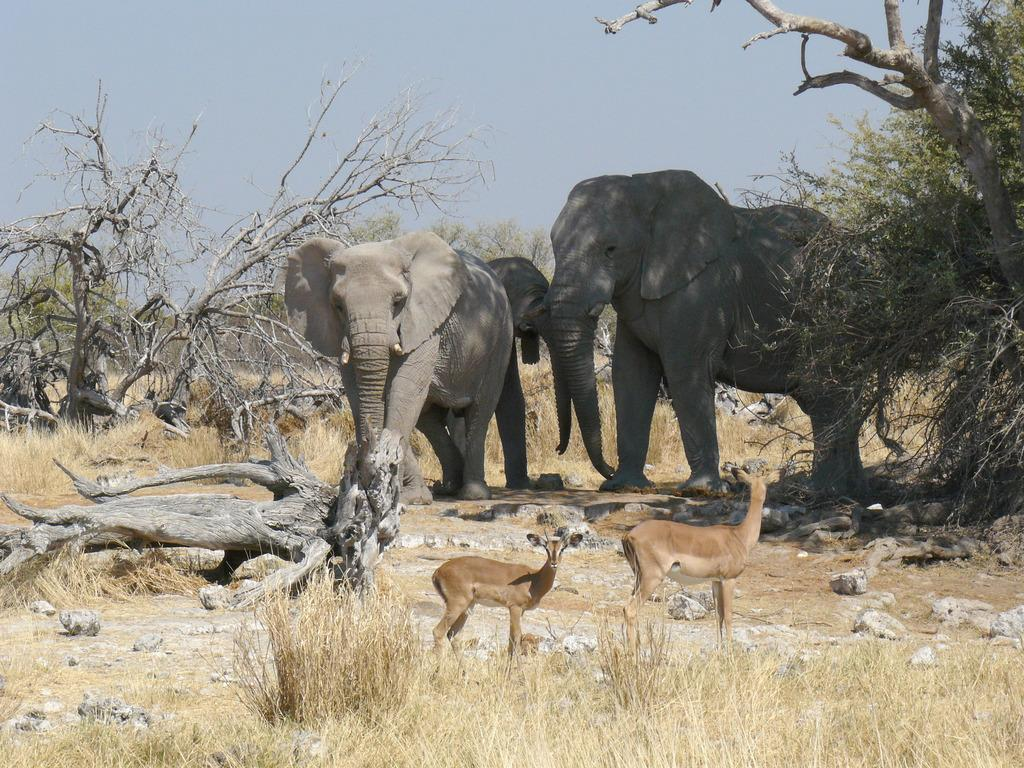What animals can be seen in the image? There are elephants and deers in the image. What type of vegetation is present in the image? There are trees and plants in the image. What other objects can be seen in the image? There are rocks in the image. What shape is the laborer using to rake the leaves in the image? There is no laborer or rake present in the image. 